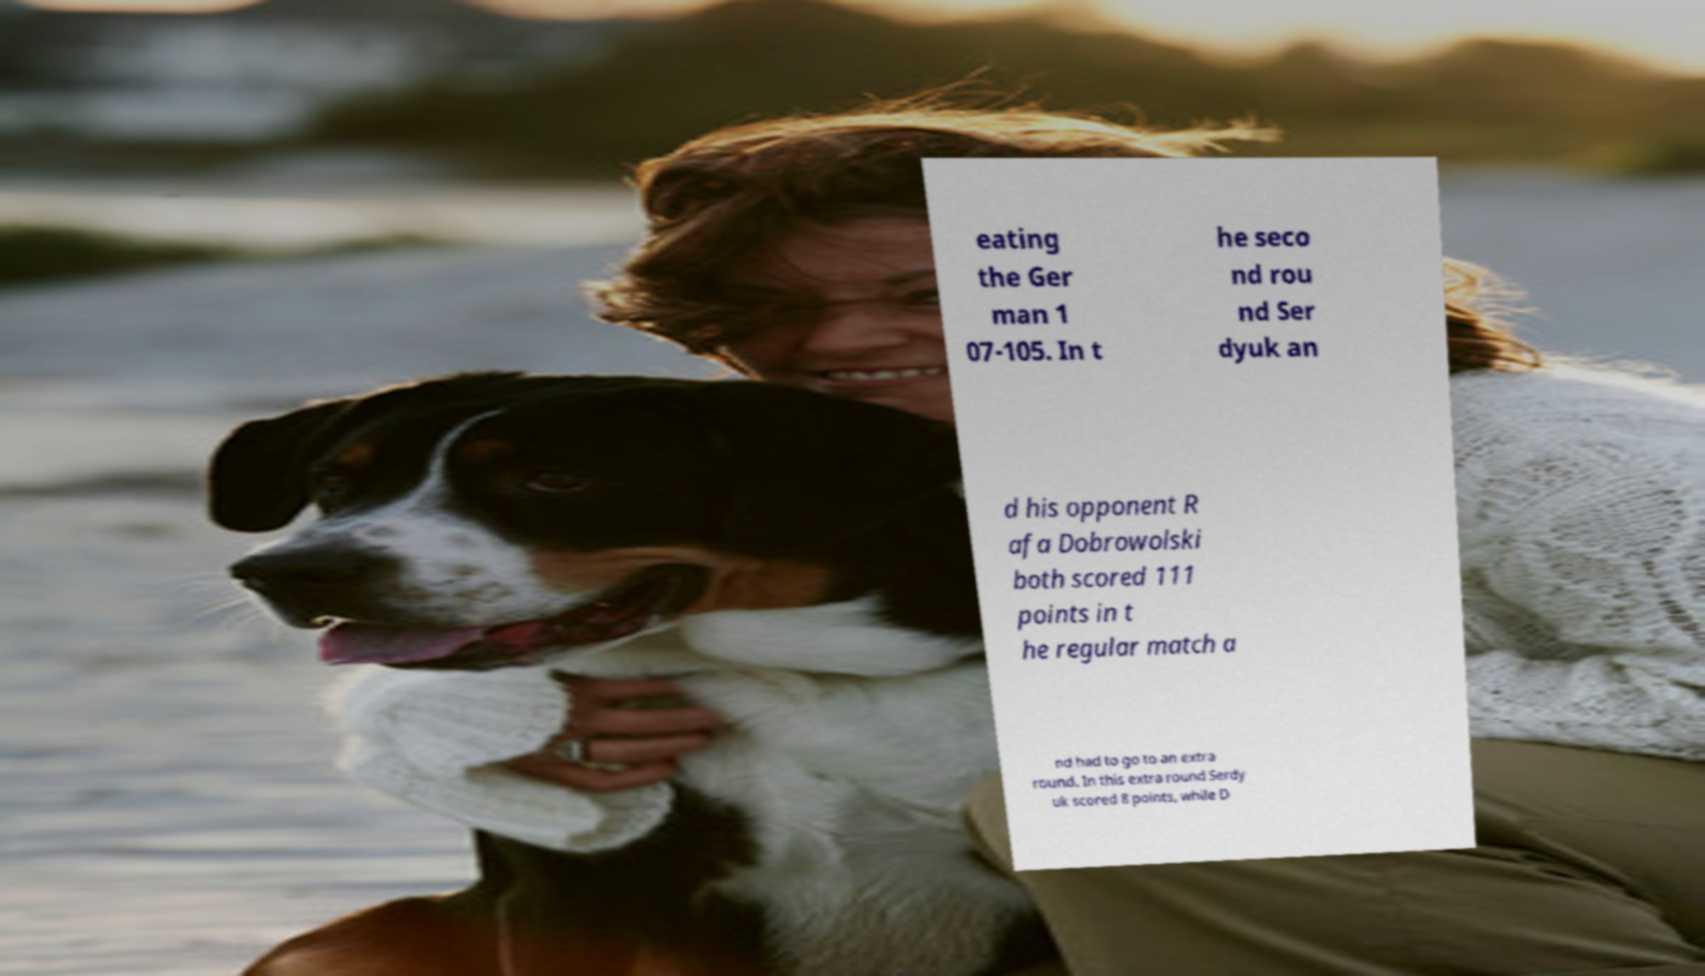There's text embedded in this image that I need extracted. Can you transcribe it verbatim? eating the Ger man 1 07-105. In t he seco nd rou nd Ser dyuk an d his opponent R afa Dobrowolski both scored 111 points in t he regular match a nd had to go to an extra round. In this extra round Serdy uk scored 8 points, while D 